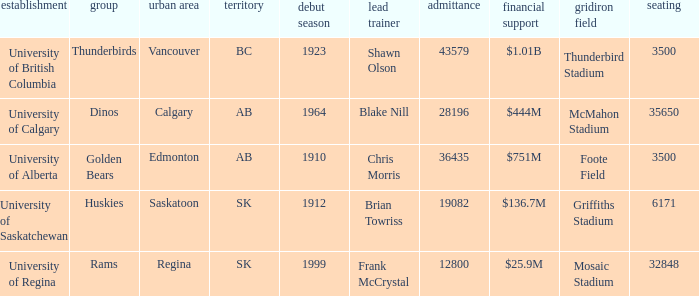How many endowments does Mosaic Stadium have? 1.0. 